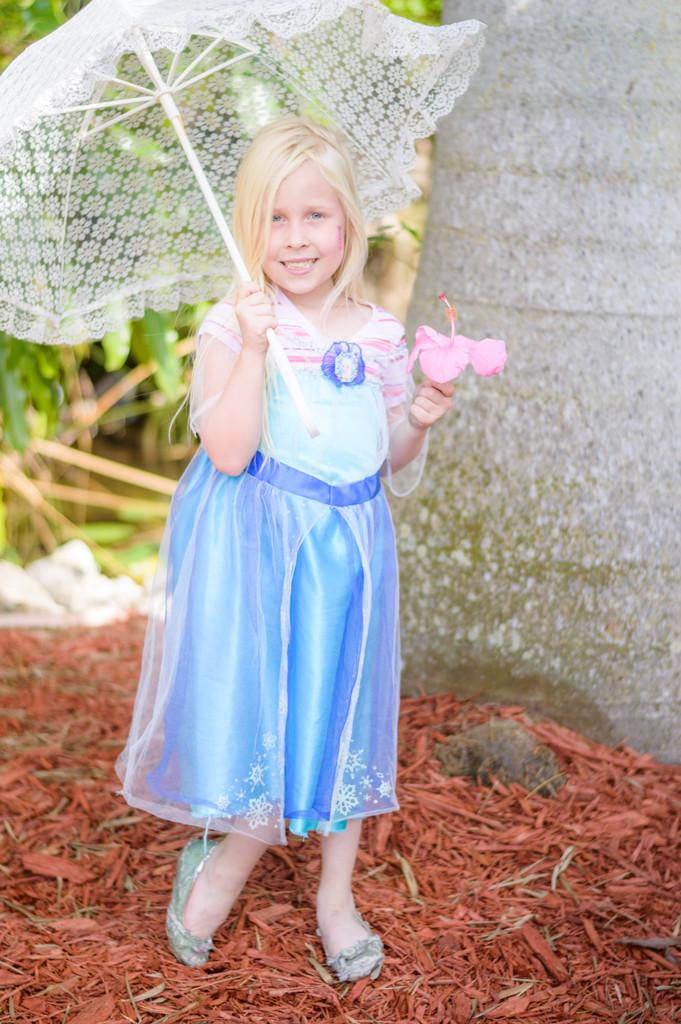Who is the main subject in the image? There is a girl in the image. What is the girl doing in the image? The girl is standing and smiling. What is the girl holding in the image? The girl is holding a flower and an umbrella. What can be seen in the background of the image? There are leaves and a wall in the background of the image. What type of stocking is the girl wearing in the image? There is no mention of stockings in the image, so it cannot be determined what type the girl might be wearing. 